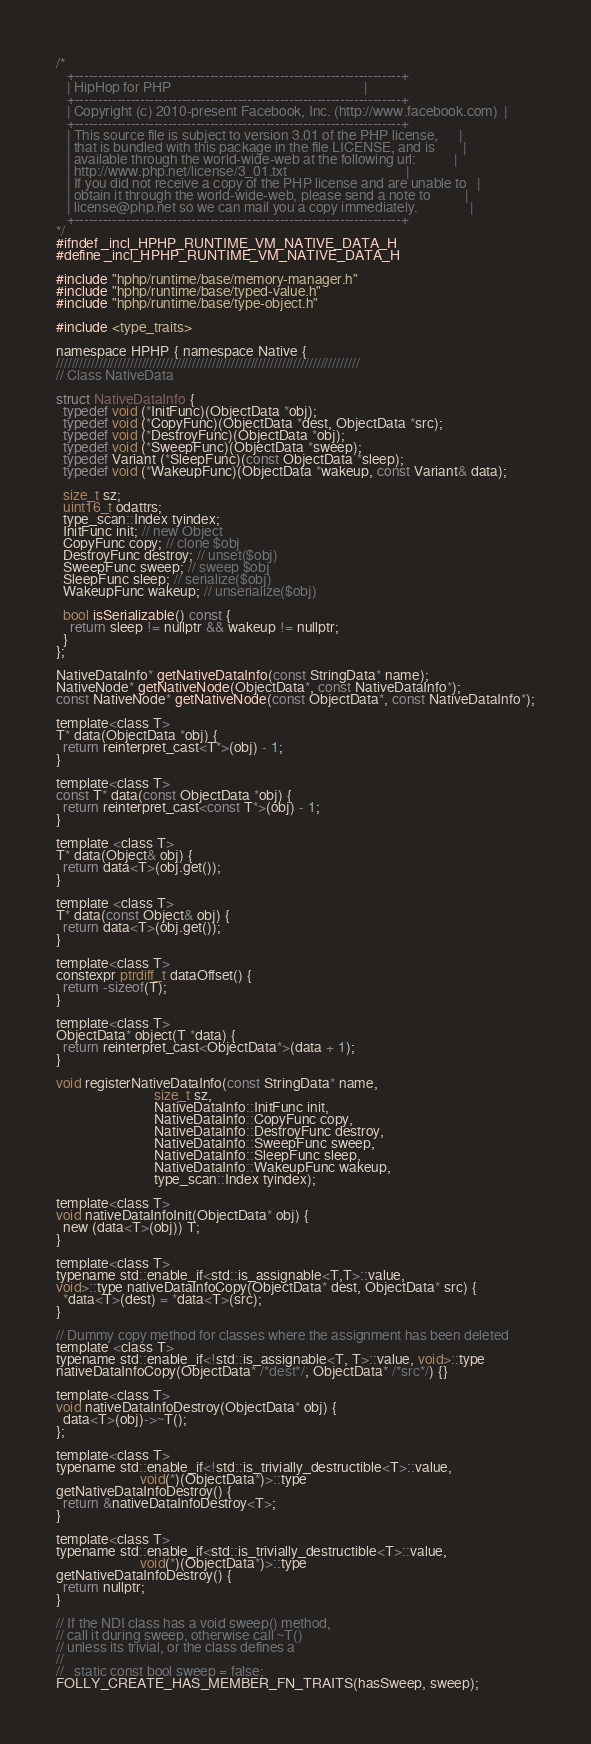<code> <loc_0><loc_0><loc_500><loc_500><_C_>/*
   +----------------------------------------------------------------------+
   | HipHop for PHP                                                       |
   +----------------------------------------------------------------------+
   | Copyright (c) 2010-present Facebook, Inc. (http://www.facebook.com)  |
   +----------------------------------------------------------------------+
   | This source file is subject to version 3.01 of the PHP license,      |
   | that is bundled with this package in the file LICENSE, and is        |
   | available through the world-wide-web at the following url:           |
   | http://www.php.net/license/3_01.txt                                  |
   | If you did not receive a copy of the PHP license and are unable to   |
   | obtain it through the world-wide-web, please send a note to          |
   | license@php.net so we can mail you a copy immediately.               |
   +----------------------------------------------------------------------+
*/
#ifndef _incl_HPHP_RUNTIME_VM_NATIVE_DATA_H
#define _incl_HPHP_RUNTIME_VM_NATIVE_DATA_H

#include "hphp/runtime/base/memory-manager.h"
#include "hphp/runtime/base/typed-value.h"
#include "hphp/runtime/base/type-object.h"

#include <type_traits>

namespace HPHP { namespace Native {
//////////////////////////////////////////////////////////////////////////////
// Class NativeData

struct NativeDataInfo {
  typedef void (*InitFunc)(ObjectData *obj);
  typedef void (*CopyFunc)(ObjectData *dest, ObjectData *src);
  typedef void (*DestroyFunc)(ObjectData *obj);
  typedef void (*SweepFunc)(ObjectData *sweep);
  typedef Variant (*SleepFunc)(const ObjectData *sleep);
  typedef void (*WakeupFunc)(ObjectData *wakeup, const Variant& data);

  size_t sz;
  uint16_t odattrs;
  type_scan::Index tyindex;
  InitFunc init; // new Object
  CopyFunc copy; // clone $obj
  DestroyFunc destroy; // unset($obj)
  SweepFunc sweep; // sweep $obj
  SleepFunc sleep; // serialize($obj)
  WakeupFunc wakeup; // unserialize($obj)

  bool isSerializable() const {
    return sleep != nullptr && wakeup != nullptr;
  }
};

NativeDataInfo* getNativeDataInfo(const StringData* name);
NativeNode* getNativeNode(ObjectData*, const NativeDataInfo*);
const NativeNode* getNativeNode(const ObjectData*, const NativeDataInfo*);

template<class T>
T* data(ObjectData *obj) {
  return reinterpret_cast<T*>(obj) - 1;
}

template<class T>
const T* data(const ObjectData *obj) {
  return reinterpret_cast<const T*>(obj) - 1;
}

template <class T>
T* data(Object& obj) {
  return data<T>(obj.get());
}

template <class T>
T* data(const Object& obj) {
  return data<T>(obj.get());
}

template<class T>
constexpr ptrdiff_t dataOffset() {
  return -sizeof(T);
}

template<class T>
ObjectData* object(T *data) {
  return reinterpret_cast<ObjectData*>(data + 1);
}

void registerNativeDataInfo(const StringData* name,
                            size_t sz,
                            NativeDataInfo::InitFunc init,
                            NativeDataInfo::CopyFunc copy,
                            NativeDataInfo::DestroyFunc destroy,
                            NativeDataInfo::SweepFunc sweep,
                            NativeDataInfo::SleepFunc sleep,
                            NativeDataInfo::WakeupFunc wakeup,
                            type_scan::Index tyindex);

template<class T>
void nativeDataInfoInit(ObjectData* obj) {
  new (data<T>(obj)) T;
}

template<class T>
typename std::enable_if<std::is_assignable<T,T>::value,
void>::type nativeDataInfoCopy(ObjectData* dest, ObjectData* src) {
  *data<T>(dest) = *data<T>(src);
}

// Dummy copy method for classes where the assignment has been deleted
template <class T>
typename std::enable_if<!std::is_assignable<T, T>::value, void>::type
nativeDataInfoCopy(ObjectData* /*dest*/, ObjectData* /*src*/) {}

template<class T>
void nativeDataInfoDestroy(ObjectData* obj) {
  data<T>(obj)->~T();
};

template<class T>
typename std::enable_if<!std::is_trivially_destructible<T>::value,
                        void(*)(ObjectData*)>::type
getNativeDataInfoDestroy() {
  return &nativeDataInfoDestroy<T>;
}

template<class T>
typename std::enable_if<std::is_trivially_destructible<T>::value,
                        void(*)(ObjectData*)>::type
getNativeDataInfoDestroy() {
  return nullptr;
}

// If the NDI class has a void sweep() method,
// call it during sweep, otherwise call ~T()
// unless its trivial, or the class defines a
//
//   static const bool sweep = false;
FOLLY_CREATE_HAS_MEMBER_FN_TRAITS(hasSweep, sweep);
</code> 